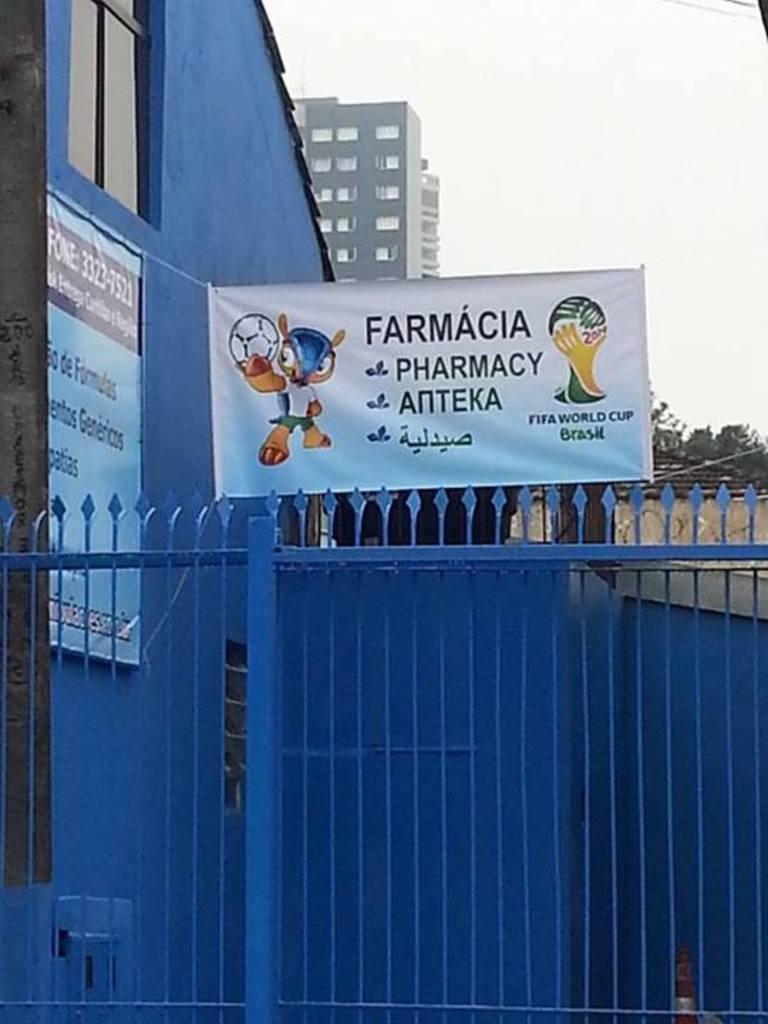<image>
Render a clear and concise summary of the photo. A banner advertising a pharmacy is hanging above a blue metal fence. 